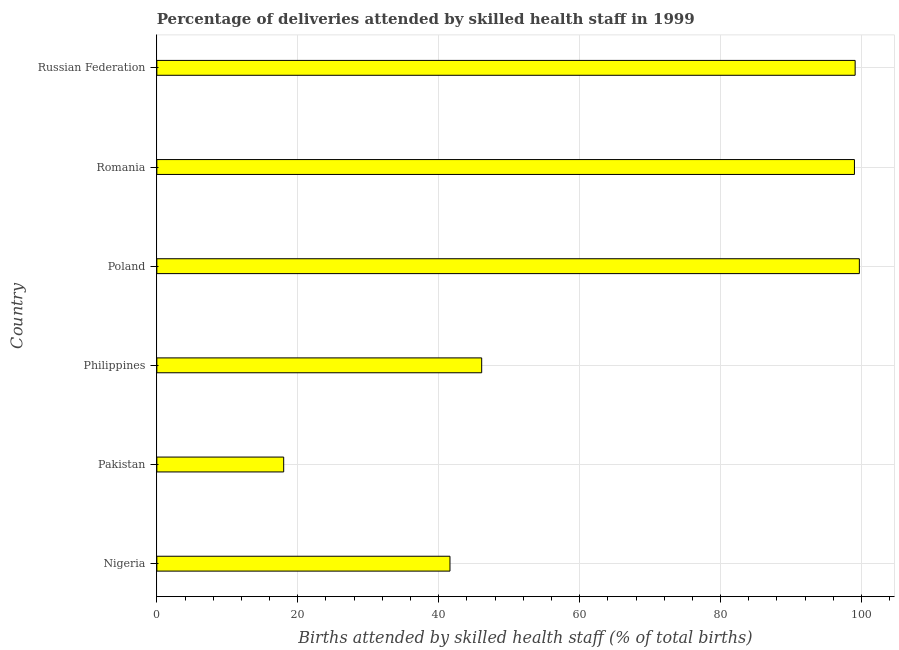Does the graph contain any zero values?
Your answer should be compact. No. What is the title of the graph?
Offer a very short reply. Percentage of deliveries attended by skilled health staff in 1999. What is the label or title of the X-axis?
Your answer should be very brief. Births attended by skilled health staff (% of total births). What is the number of births attended by skilled health staff in Nigeria?
Provide a succinct answer. 41.6. Across all countries, what is the maximum number of births attended by skilled health staff?
Make the answer very short. 99.7. Across all countries, what is the minimum number of births attended by skilled health staff?
Give a very brief answer. 18. In which country was the number of births attended by skilled health staff maximum?
Make the answer very short. Poland. In which country was the number of births attended by skilled health staff minimum?
Your answer should be very brief. Pakistan. What is the sum of the number of births attended by skilled health staff?
Provide a short and direct response. 403.5. What is the average number of births attended by skilled health staff per country?
Offer a very short reply. 67.25. What is the median number of births attended by skilled health staff?
Provide a succinct answer. 72.55. In how many countries, is the number of births attended by skilled health staff greater than 24 %?
Provide a succinct answer. 5. What is the ratio of the number of births attended by skilled health staff in Nigeria to that in Poland?
Provide a short and direct response. 0.42. Is the number of births attended by skilled health staff in Nigeria less than that in Pakistan?
Your answer should be compact. No. What is the difference between the highest and the second highest number of births attended by skilled health staff?
Provide a short and direct response. 0.6. Is the sum of the number of births attended by skilled health staff in Philippines and Romania greater than the maximum number of births attended by skilled health staff across all countries?
Your response must be concise. Yes. What is the difference between the highest and the lowest number of births attended by skilled health staff?
Make the answer very short. 81.7. How many bars are there?
Ensure brevity in your answer.  6. Are all the bars in the graph horizontal?
Offer a very short reply. Yes. How many countries are there in the graph?
Your answer should be very brief. 6. What is the difference between two consecutive major ticks on the X-axis?
Your answer should be compact. 20. What is the Births attended by skilled health staff (% of total births) in Nigeria?
Keep it short and to the point. 41.6. What is the Births attended by skilled health staff (% of total births) of Philippines?
Your answer should be very brief. 46.1. What is the Births attended by skilled health staff (% of total births) of Poland?
Your answer should be very brief. 99.7. What is the Births attended by skilled health staff (% of total births) of Russian Federation?
Give a very brief answer. 99.1. What is the difference between the Births attended by skilled health staff (% of total births) in Nigeria and Pakistan?
Make the answer very short. 23.6. What is the difference between the Births attended by skilled health staff (% of total births) in Nigeria and Poland?
Give a very brief answer. -58.1. What is the difference between the Births attended by skilled health staff (% of total births) in Nigeria and Romania?
Ensure brevity in your answer.  -57.4. What is the difference between the Births attended by skilled health staff (% of total births) in Nigeria and Russian Federation?
Your answer should be very brief. -57.5. What is the difference between the Births attended by skilled health staff (% of total births) in Pakistan and Philippines?
Keep it short and to the point. -28.1. What is the difference between the Births attended by skilled health staff (% of total births) in Pakistan and Poland?
Give a very brief answer. -81.7. What is the difference between the Births attended by skilled health staff (% of total births) in Pakistan and Romania?
Give a very brief answer. -81. What is the difference between the Births attended by skilled health staff (% of total births) in Pakistan and Russian Federation?
Offer a terse response. -81.1. What is the difference between the Births attended by skilled health staff (% of total births) in Philippines and Poland?
Your answer should be compact. -53.6. What is the difference between the Births attended by skilled health staff (% of total births) in Philippines and Romania?
Your response must be concise. -52.9. What is the difference between the Births attended by skilled health staff (% of total births) in Philippines and Russian Federation?
Your answer should be compact. -53. What is the difference between the Births attended by skilled health staff (% of total births) in Poland and Russian Federation?
Make the answer very short. 0.6. What is the ratio of the Births attended by skilled health staff (% of total births) in Nigeria to that in Pakistan?
Ensure brevity in your answer.  2.31. What is the ratio of the Births attended by skilled health staff (% of total births) in Nigeria to that in Philippines?
Provide a succinct answer. 0.9. What is the ratio of the Births attended by skilled health staff (% of total births) in Nigeria to that in Poland?
Give a very brief answer. 0.42. What is the ratio of the Births attended by skilled health staff (% of total births) in Nigeria to that in Romania?
Provide a short and direct response. 0.42. What is the ratio of the Births attended by skilled health staff (% of total births) in Nigeria to that in Russian Federation?
Ensure brevity in your answer.  0.42. What is the ratio of the Births attended by skilled health staff (% of total births) in Pakistan to that in Philippines?
Your response must be concise. 0.39. What is the ratio of the Births attended by skilled health staff (% of total births) in Pakistan to that in Poland?
Provide a short and direct response. 0.18. What is the ratio of the Births attended by skilled health staff (% of total births) in Pakistan to that in Romania?
Make the answer very short. 0.18. What is the ratio of the Births attended by skilled health staff (% of total births) in Pakistan to that in Russian Federation?
Your answer should be compact. 0.18. What is the ratio of the Births attended by skilled health staff (% of total births) in Philippines to that in Poland?
Offer a terse response. 0.46. What is the ratio of the Births attended by skilled health staff (% of total births) in Philippines to that in Romania?
Your response must be concise. 0.47. What is the ratio of the Births attended by skilled health staff (% of total births) in Philippines to that in Russian Federation?
Provide a short and direct response. 0.47. What is the ratio of the Births attended by skilled health staff (% of total births) in Poland to that in Romania?
Offer a terse response. 1.01. 